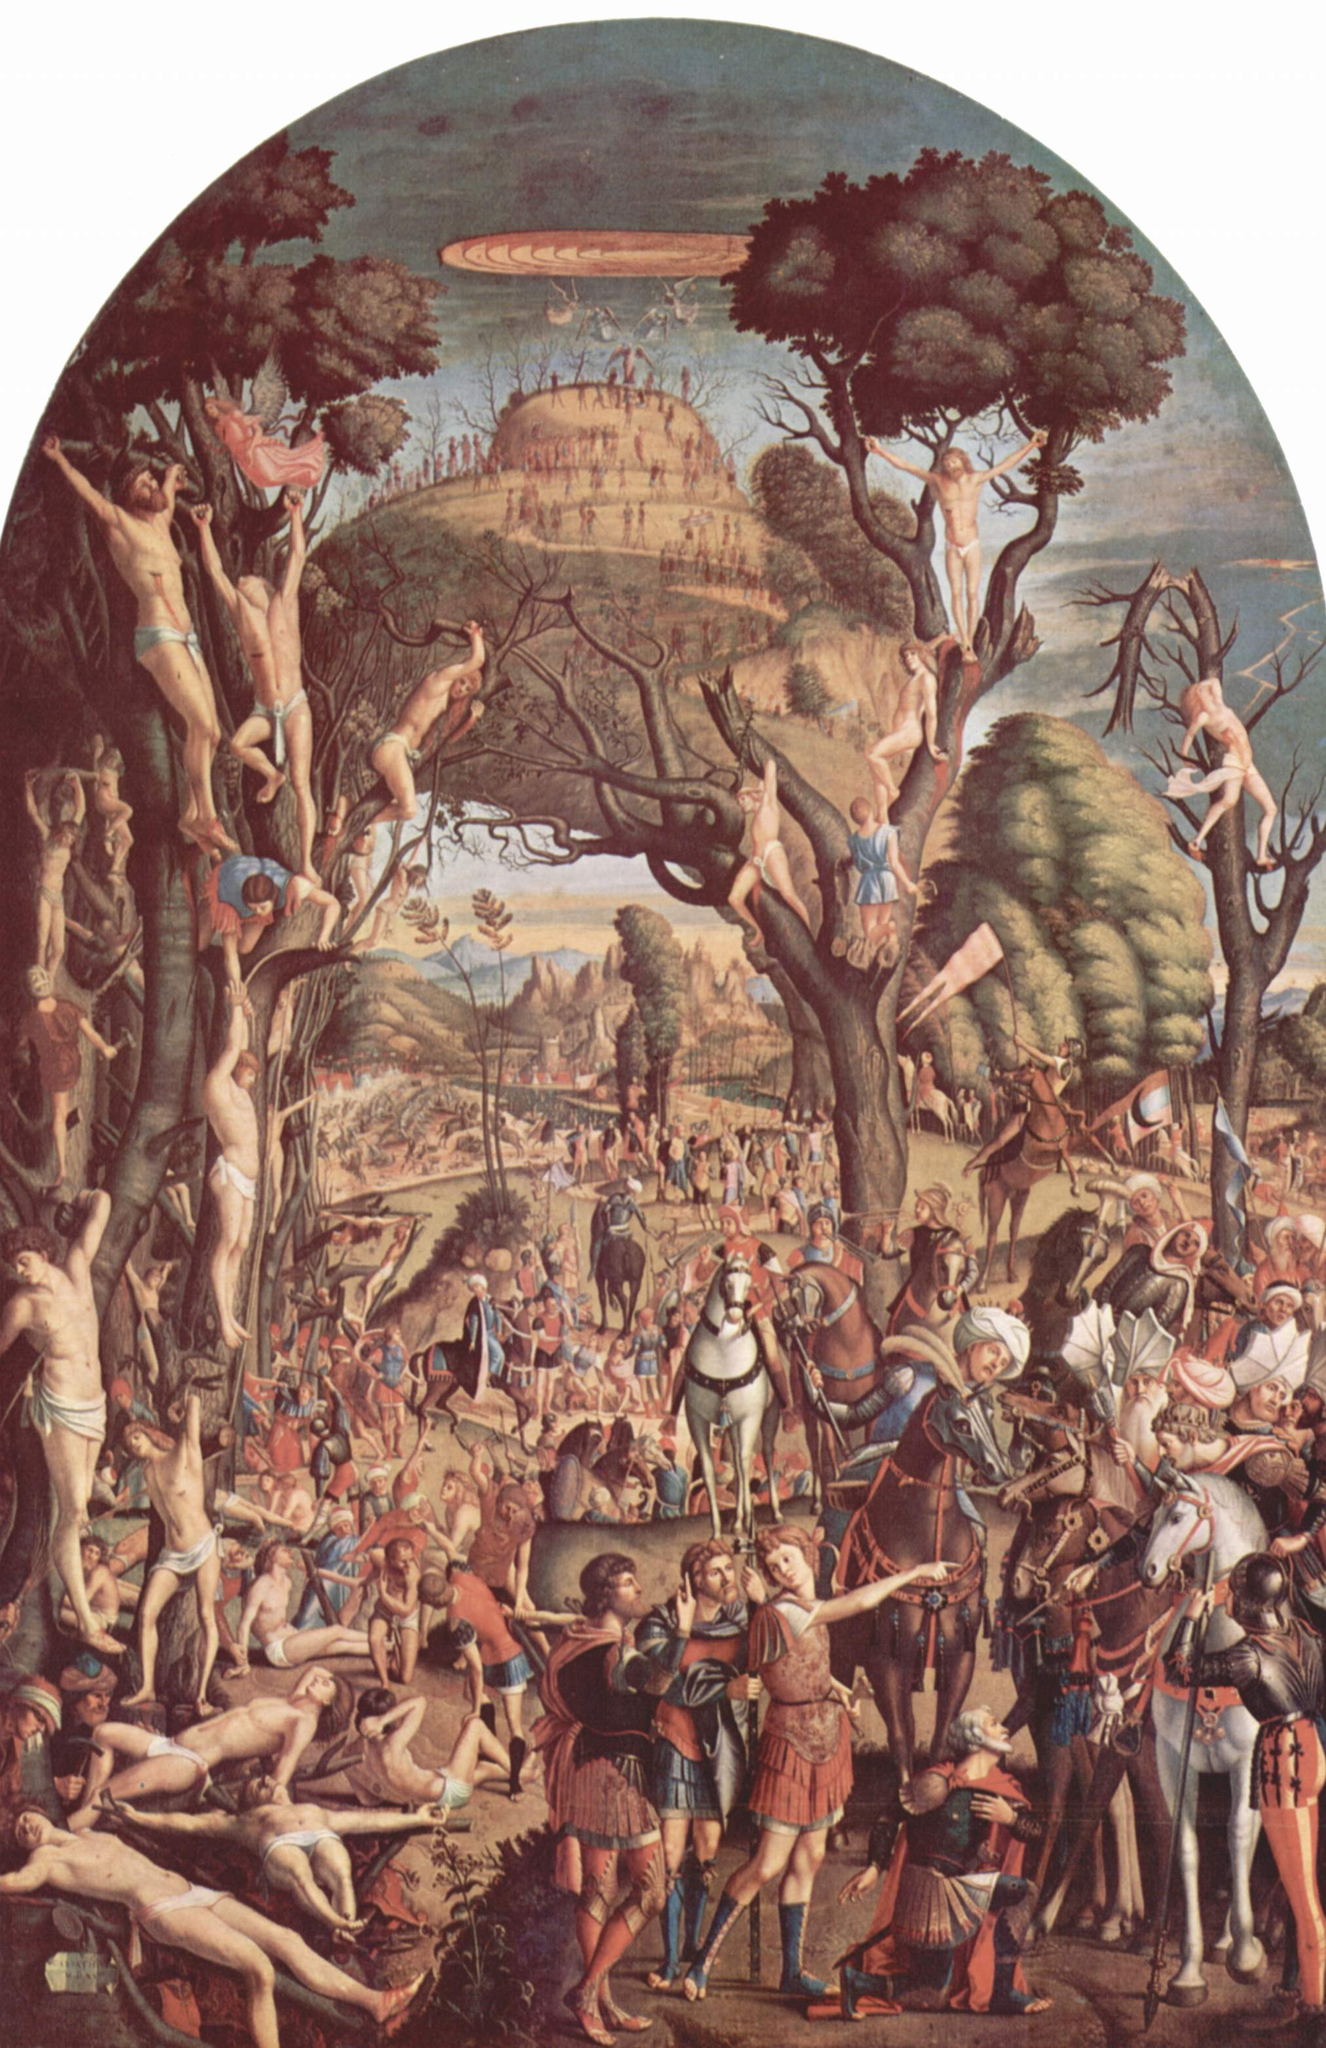Describe the role of the contrasting groups of people in the lower part of the painting. The lower section of the painting features diverse groups that bring a stark contrast to the whimsical scene above. The soldiers and knight on horseback, dressed in period armor and engaging in what appears to be a mission or campaign, embody the era's martial and societal order. Their presence introduces themes of duty, valor, and possibly conquest, emphasizing the societal norms and expectations of the Renaissance period. On the other hand, the subdued civilians, perhaps onlookers or victims, might represent the everyday populace, impacted by the decisions and conflicts of the higher powers. This dichotomy enhances the painting's narrative depth, reflecting on the coexistence of everyday life with significant historical events. 